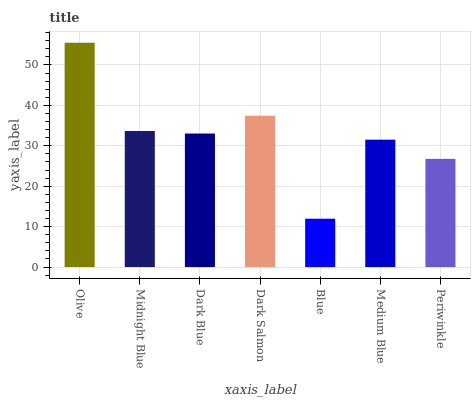Is Blue the minimum?
Answer yes or no. Yes. Is Olive the maximum?
Answer yes or no. Yes. Is Midnight Blue the minimum?
Answer yes or no. No. Is Midnight Blue the maximum?
Answer yes or no. No. Is Olive greater than Midnight Blue?
Answer yes or no. Yes. Is Midnight Blue less than Olive?
Answer yes or no. Yes. Is Midnight Blue greater than Olive?
Answer yes or no. No. Is Olive less than Midnight Blue?
Answer yes or no. No. Is Dark Blue the high median?
Answer yes or no. Yes. Is Dark Blue the low median?
Answer yes or no. Yes. Is Dark Salmon the high median?
Answer yes or no. No. Is Blue the low median?
Answer yes or no. No. 